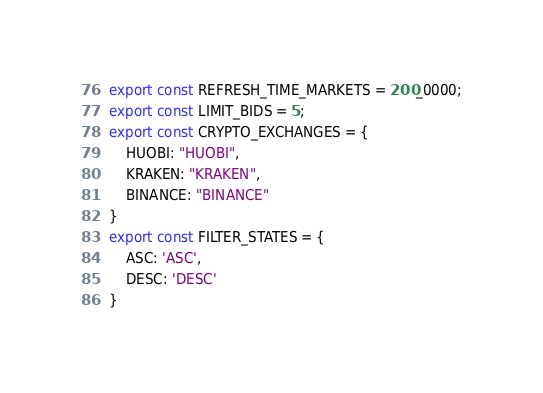Convert code to text. <code><loc_0><loc_0><loc_500><loc_500><_JavaScript_>export const REFRESH_TIME_MARKETS = 200_0000;
export const LIMIT_BIDS = 5;
export const CRYPTO_EXCHANGES = {
    HUOBI: "HUOBI",
    KRAKEN: "KRAKEN",
    BINANCE: "BINANCE"
}
export const FILTER_STATES = {
    ASC: 'ASC',
    DESC: 'DESC'
}</code> 